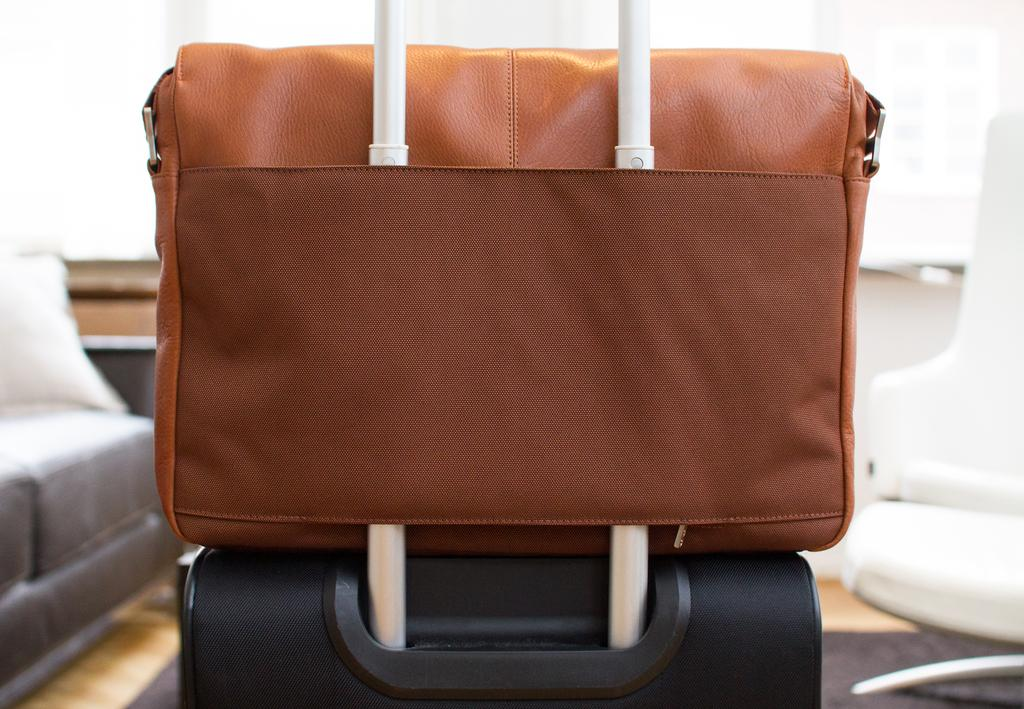What object is located on the left side of the image? There is a bag on the left side of the image. What type of furniture can be seen in the image? There is a couch in the image. What type of humor is depicted on the calendar in the image? There is no calendar present in the image, so it is not possible to determine what type of humor might be depicted. 